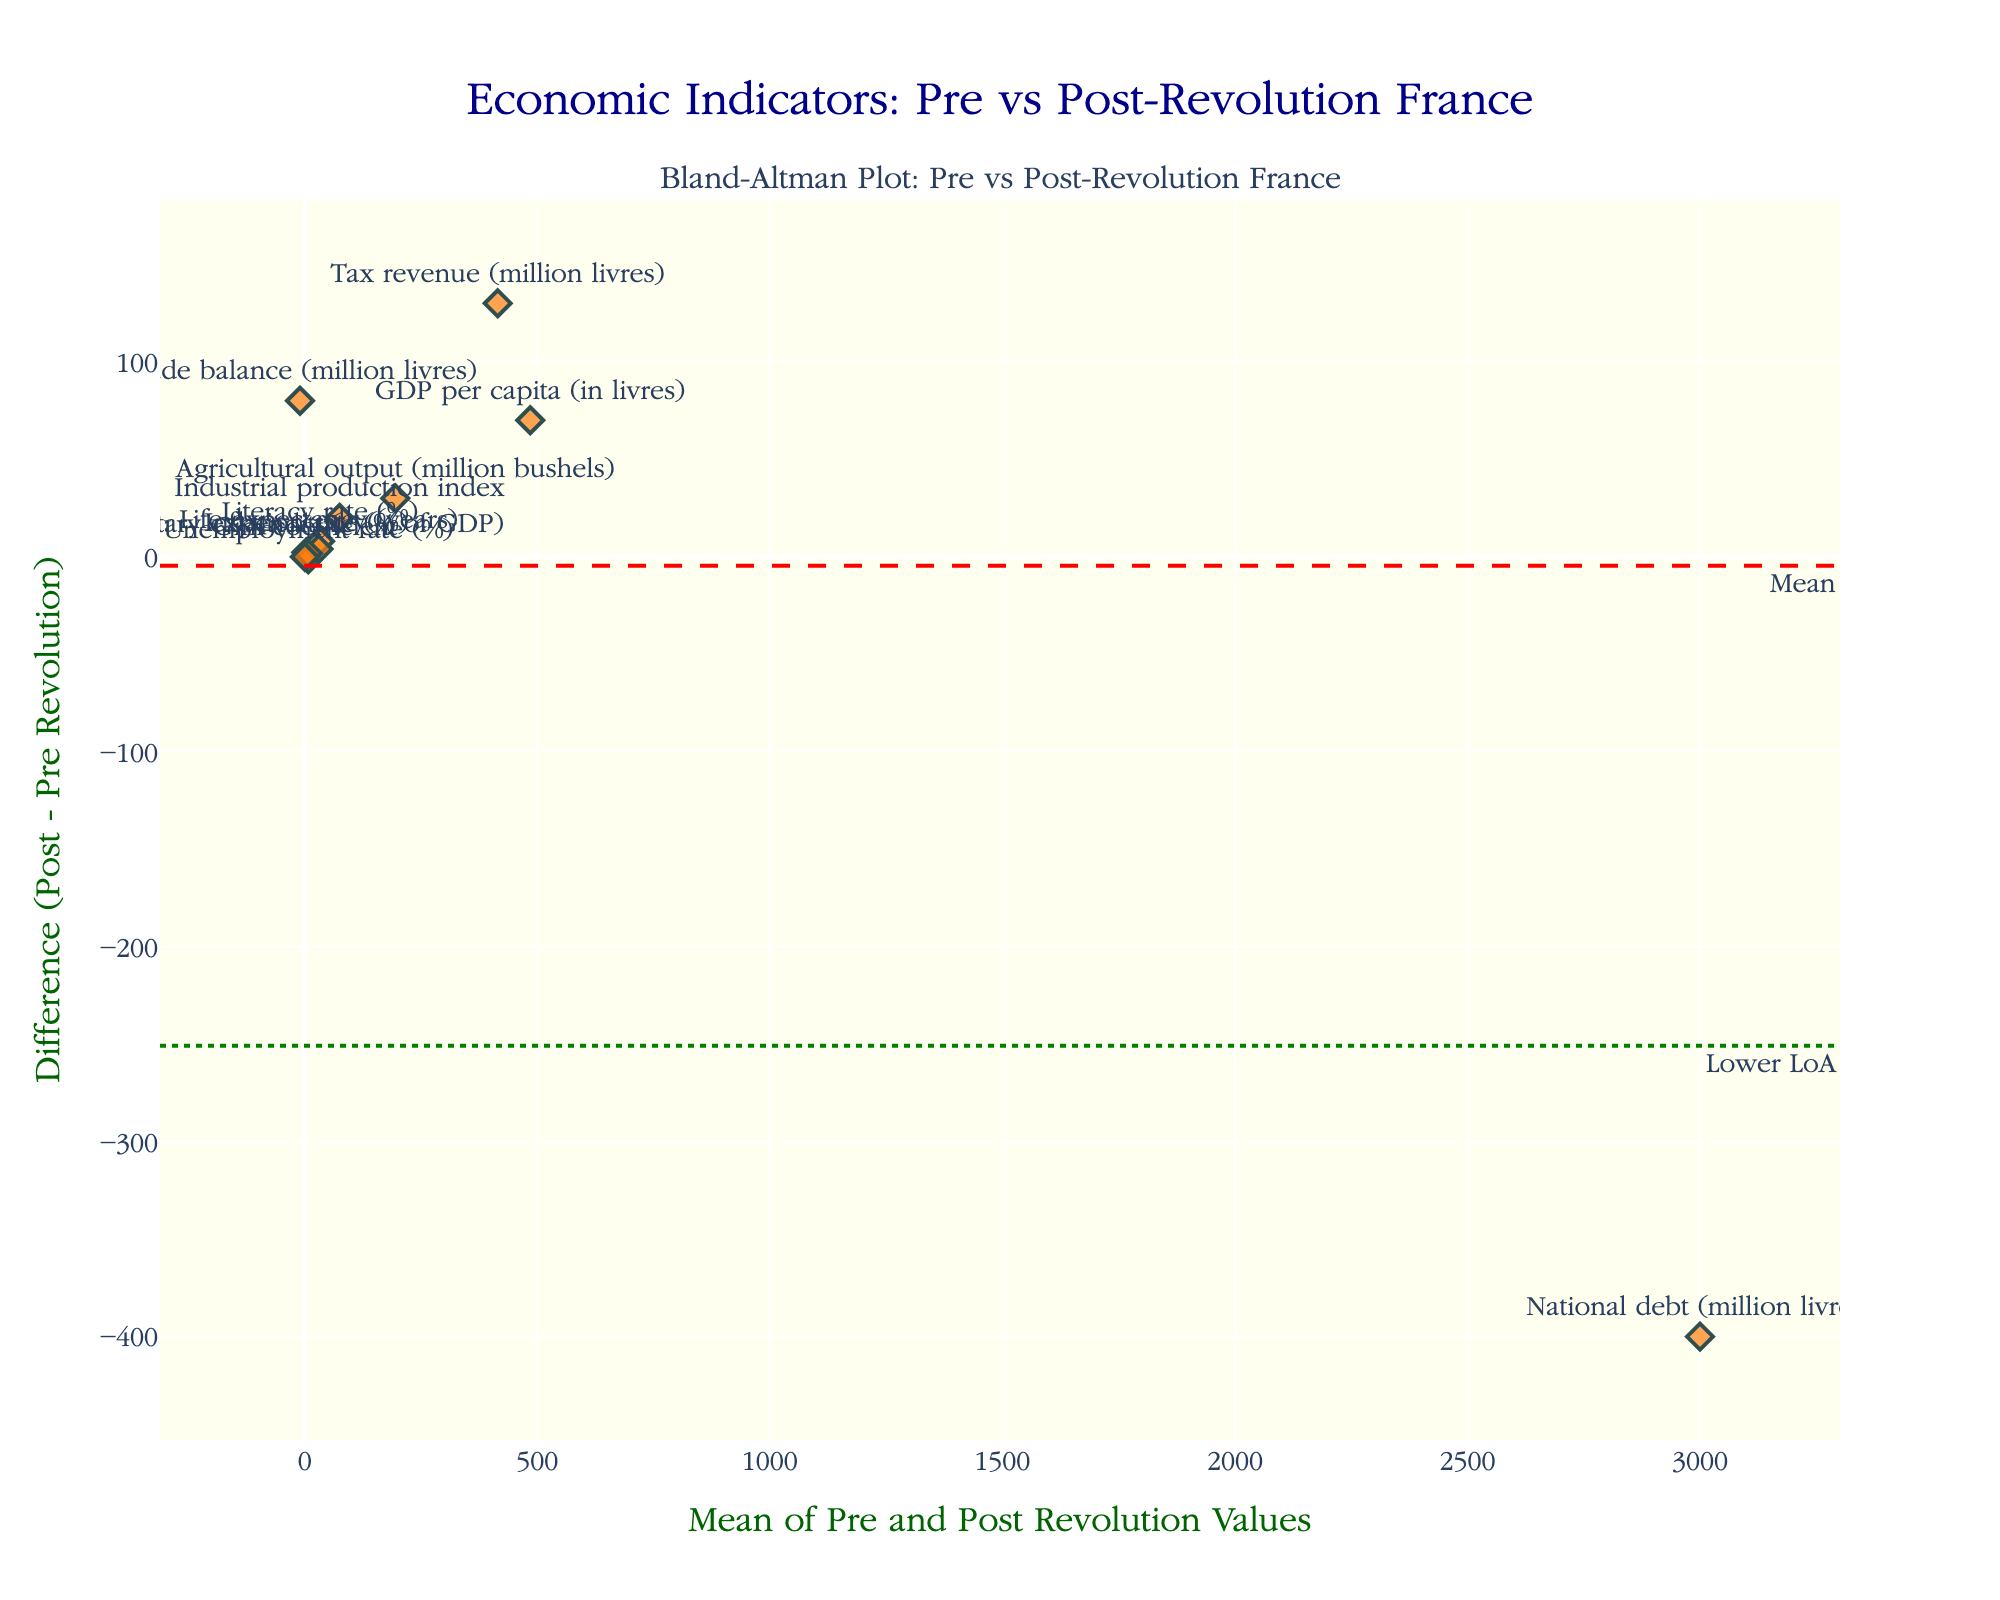What is the title of the figure? The title of the figure is displayed at the top in a larger font. It reads "Economic Indicators: Pre vs Post-Revolution France".
Answer: Economic Indicators: Pre vs Post-Revolution France How many data points are shown in the plot? By counting the markers (diamonds) on the plot, we see there are 11 data points, one for each economic indicator.
Answer: 11 What is the range of the x-axis (mean values)? The x-axis range can be determined by the minimum and maximum values of the mean of pre and post-revolution values. The plot's x-axis starts just below the smallest mean value and extends just above the largest mean value.
Answer: Around 20 to 3000 What is the mean difference between pre- and post-revolution values? The mean difference is represented by the red dashed line across the plot. The corresponding y-axis value where this line is located is the mean difference.
Answer: Around 44 Which indicator has the largest positive difference between post-revolution and pre-revolution values? By observing the y-axis, the highest marker in the positive direction represents the largest positive difference. The text label for this point indicates the indicator.
Answer: Trade balance Which indicator shows a negative difference between pre-revolution and post-revolution values? The indicators located below the zero line on the y-axis have negative differences. By checking these points, we identify the indicators.
Answer: National debt What are the values of the limits of agreement in the plot? The limits of agreement are shown as two green dotted lines above and below the mean difference. The y-axis values where these lines are located denote the limits.
Answer: Approximately -78 and 166 What is the mean value (x-axis) of the 'Military expenditure (% of GDP)' indicator? Using the label for 'Military expenditure (% of GDP)' and locating it on the x-axis, the mean value is given by its horizontal position.
Answer: Approximately 7.35 How is the plot useful for comparing pre- and post-revolution economic indicators? The Bland-Altman plot shows the agreement between two sets of measurements by plotting the differences against their averages. This helps identify any systematic biases and the range of agreement, making it clear whether the post-revolution values generally increased or decreased compared to pre-revolution.
Answer: Identifies system biases and agreements What does it mean if a data point is far from the mean difference line? A data point far from the mean difference line indicates a large discrepancy between the pre- and post-revolution values for that indicator, suggesting a significant change between the two periods.
Answer: Significant change 